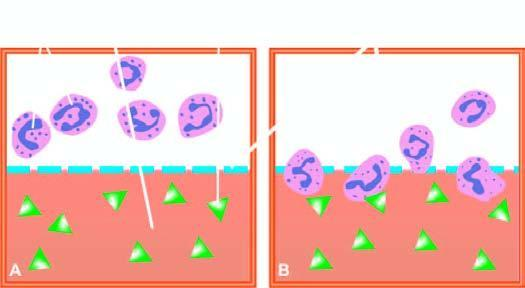s suspension of leucocytes above separated from test solution below?
Answer the question using a single word or phrase. Yes 